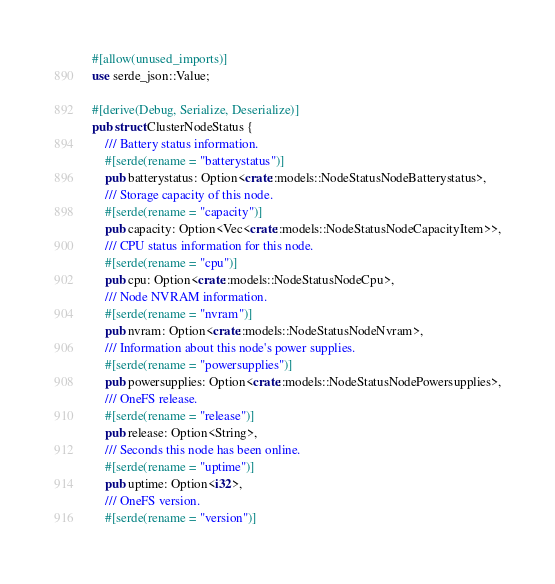<code> <loc_0><loc_0><loc_500><loc_500><_Rust_>#[allow(unused_imports)]
use serde_json::Value;

#[derive(Debug, Serialize, Deserialize)]
pub struct ClusterNodeStatus {
    /// Battery status information.
    #[serde(rename = "batterystatus")]
    pub batterystatus: Option<crate::models::NodeStatusNodeBatterystatus>,
    /// Storage capacity of this node.
    #[serde(rename = "capacity")]
    pub capacity: Option<Vec<crate::models::NodeStatusNodeCapacityItem>>,
    /// CPU status information for this node.
    #[serde(rename = "cpu")]
    pub cpu: Option<crate::models::NodeStatusNodeCpu>,
    /// Node NVRAM information.
    #[serde(rename = "nvram")]
    pub nvram: Option<crate::models::NodeStatusNodeNvram>,
    /// Information about this node's power supplies.
    #[serde(rename = "powersupplies")]
    pub powersupplies: Option<crate::models::NodeStatusNodePowersupplies>,
    /// OneFS release.
    #[serde(rename = "release")]
    pub release: Option<String>,
    /// Seconds this node has been online.
    #[serde(rename = "uptime")]
    pub uptime: Option<i32>,
    /// OneFS version.
    #[serde(rename = "version")]</code> 